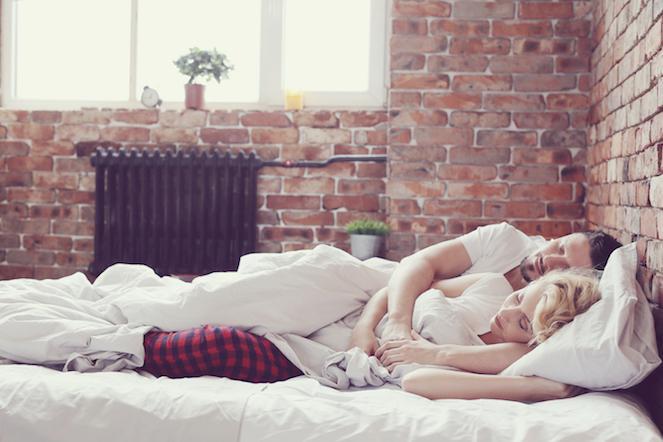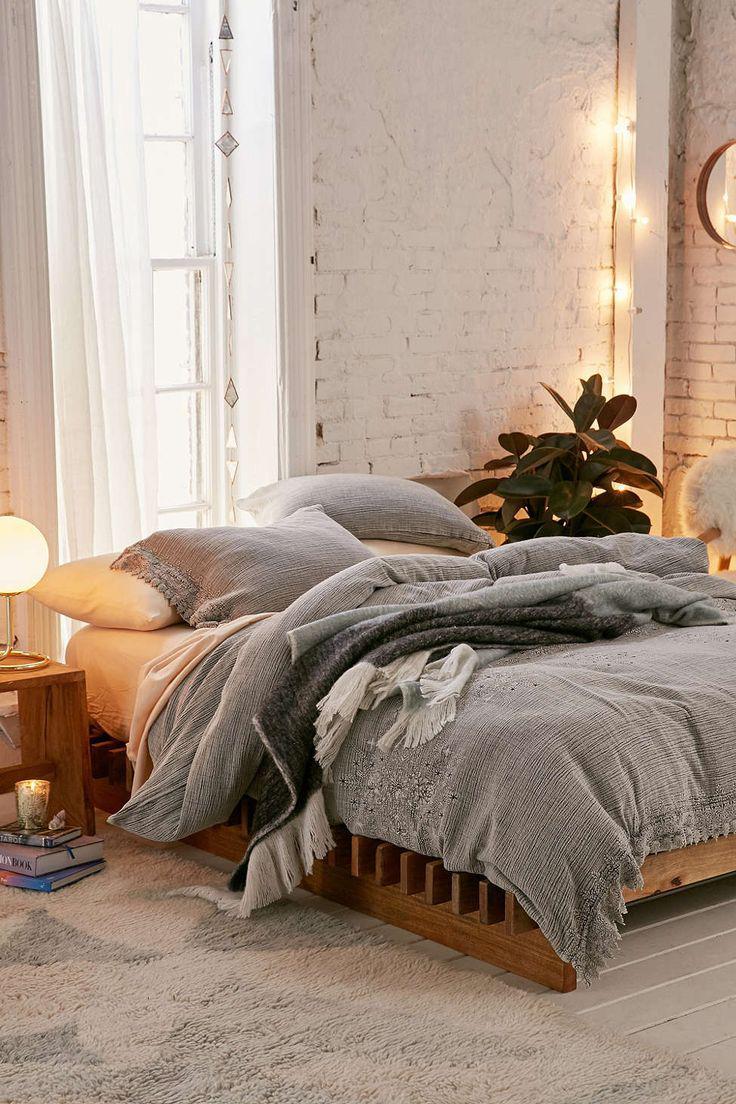The first image is the image on the left, the second image is the image on the right. Assess this claim about the two images: "There are stuffed animals on a bed.". Correct or not? Answer yes or no. No. The first image is the image on the left, the second image is the image on the right. Considering the images on both sides, is "A pale neutral-colored sofa is topped with a row of at least three colorful square throw pillows in one image." valid? Answer yes or no. No. 